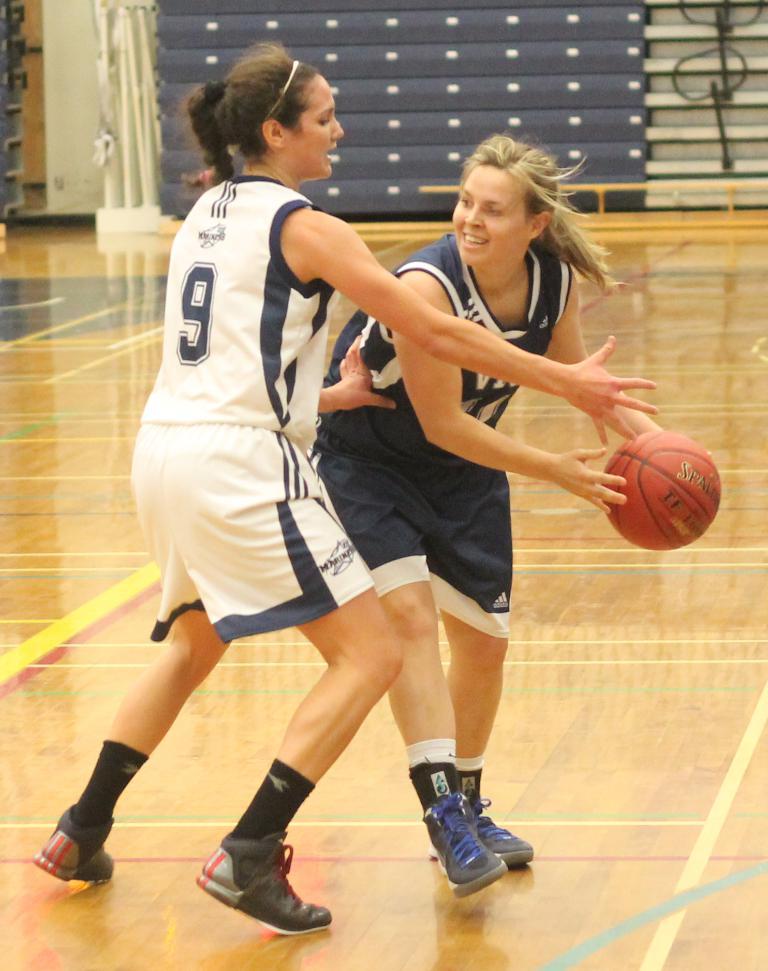What is the player number of the girl in the white jersey?
Your answer should be very brief. 9. 